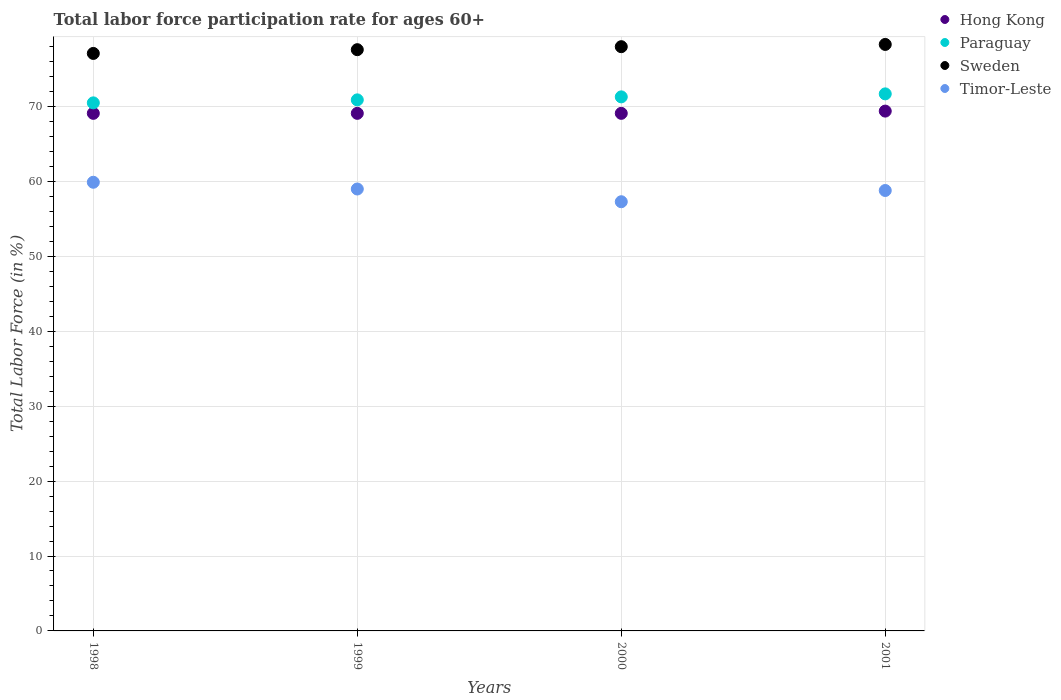Is the number of dotlines equal to the number of legend labels?
Provide a succinct answer. Yes. What is the labor force participation rate in Timor-Leste in 2001?
Your answer should be compact. 58.8. Across all years, what is the maximum labor force participation rate in Timor-Leste?
Provide a short and direct response. 59.9. Across all years, what is the minimum labor force participation rate in Timor-Leste?
Provide a succinct answer. 57.3. What is the total labor force participation rate in Paraguay in the graph?
Give a very brief answer. 284.4. What is the difference between the labor force participation rate in Paraguay in 1998 and that in 2001?
Make the answer very short. -1.2. What is the difference between the labor force participation rate in Timor-Leste in 1999 and the labor force participation rate in Paraguay in 2000?
Your answer should be compact. -12.3. What is the average labor force participation rate in Paraguay per year?
Your answer should be very brief. 71.1. In how many years, is the labor force participation rate in Timor-Leste greater than 28 %?
Keep it short and to the point. 4. What is the ratio of the labor force participation rate in Sweden in 1998 to that in 1999?
Offer a very short reply. 0.99. What is the difference between the highest and the second highest labor force participation rate in Sweden?
Offer a very short reply. 0.3. What is the difference between the highest and the lowest labor force participation rate in Hong Kong?
Keep it short and to the point. 0.3. In how many years, is the labor force participation rate in Hong Kong greater than the average labor force participation rate in Hong Kong taken over all years?
Your response must be concise. 1. Is it the case that in every year, the sum of the labor force participation rate in Sweden and labor force participation rate in Paraguay  is greater than the sum of labor force participation rate in Hong Kong and labor force participation rate in Timor-Leste?
Offer a very short reply. Yes. Is the labor force participation rate in Paraguay strictly less than the labor force participation rate in Sweden over the years?
Offer a very short reply. Yes. How many years are there in the graph?
Provide a short and direct response. 4. Where does the legend appear in the graph?
Offer a very short reply. Top right. What is the title of the graph?
Ensure brevity in your answer.  Total labor force participation rate for ages 60+. What is the Total Labor Force (in %) of Hong Kong in 1998?
Ensure brevity in your answer.  69.1. What is the Total Labor Force (in %) of Paraguay in 1998?
Offer a very short reply. 70.5. What is the Total Labor Force (in %) in Sweden in 1998?
Keep it short and to the point. 77.1. What is the Total Labor Force (in %) in Timor-Leste in 1998?
Your response must be concise. 59.9. What is the Total Labor Force (in %) in Hong Kong in 1999?
Make the answer very short. 69.1. What is the Total Labor Force (in %) in Paraguay in 1999?
Make the answer very short. 70.9. What is the Total Labor Force (in %) of Sweden in 1999?
Your response must be concise. 77.6. What is the Total Labor Force (in %) of Timor-Leste in 1999?
Your response must be concise. 59. What is the Total Labor Force (in %) in Hong Kong in 2000?
Your response must be concise. 69.1. What is the Total Labor Force (in %) of Paraguay in 2000?
Offer a very short reply. 71.3. What is the Total Labor Force (in %) in Timor-Leste in 2000?
Your response must be concise. 57.3. What is the Total Labor Force (in %) in Hong Kong in 2001?
Make the answer very short. 69.4. What is the Total Labor Force (in %) of Paraguay in 2001?
Offer a very short reply. 71.7. What is the Total Labor Force (in %) of Sweden in 2001?
Your response must be concise. 78.3. What is the Total Labor Force (in %) of Timor-Leste in 2001?
Ensure brevity in your answer.  58.8. Across all years, what is the maximum Total Labor Force (in %) in Hong Kong?
Offer a terse response. 69.4. Across all years, what is the maximum Total Labor Force (in %) of Paraguay?
Keep it short and to the point. 71.7. Across all years, what is the maximum Total Labor Force (in %) in Sweden?
Provide a succinct answer. 78.3. Across all years, what is the maximum Total Labor Force (in %) in Timor-Leste?
Keep it short and to the point. 59.9. Across all years, what is the minimum Total Labor Force (in %) in Hong Kong?
Your answer should be compact. 69.1. Across all years, what is the minimum Total Labor Force (in %) of Paraguay?
Ensure brevity in your answer.  70.5. Across all years, what is the minimum Total Labor Force (in %) in Sweden?
Ensure brevity in your answer.  77.1. Across all years, what is the minimum Total Labor Force (in %) of Timor-Leste?
Provide a short and direct response. 57.3. What is the total Total Labor Force (in %) in Hong Kong in the graph?
Your answer should be very brief. 276.7. What is the total Total Labor Force (in %) of Paraguay in the graph?
Your answer should be very brief. 284.4. What is the total Total Labor Force (in %) of Sweden in the graph?
Your answer should be very brief. 311. What is the total Total Labor Force (in %) in Timor-Leste in the graph?
Offer a very short reply. 235. What is the difference between the Total Labor Force (in %) in Hong Kong in 1998 and that in 1999?
Give a very brief answer. 0. What is the difference between the Total Labor Force (in %) of Paraguay in 1998 and that in 1999?
Your answer should be very brief. -0.4. What is the difference between the Total Labor Force (in %) of Sweden in 1998 and that in 1999?
Offer a very short reply. -0.5. What is the difference between the Total Labor Force (in %) in Timor-Leste in 1998 and that in 1999?
Your answer should be very brief. 0.9. What is the difference between the Total Labor Force (in %) in Paraguay in 1998 and that in 2000?
Ensure brevity in your answer.  -0.8. What is the difference between the Total Labor Force (in %) in Timor-Leste in 1998 and that in 2000?
Provide a short and direct response. 2.6. What is the difference between the Total Labor Force (in %) in Paraguay in 1998 and that in 2001?
Offer a very short reply. -1.2. What is the difference between the Total Labor Force (in %) of Sweden in 1998 and that in 2001?
Offer a terse response. -1.2. What is the difference between the Total Labor Force (in %) in Timor-Leste in 1998 and that in 2001?
Keep it short and to the point. 1.1. What is the difference between the Total Labor Force (in %) of Hong Kong in 1999 and that in 2000?
Offer a very short reply. 0. What is the difference between the Total Labor Force (in %) of Paraguay in 1999 and that in 2000?
Your answer should be very brief. -0.4. What is the difference between the Total Labor Force (in %) of Sweden in 1999 and that in 2001?
Your answer should be very brief. -0.7. What is the difference between the Total Labor Force (in %) of Timor-Leste in 1999 and that in 2001?
Ensure brevity in your answer.  0.2. What is the difference between the Total Labor Force (in %) in Sweden in 2000 and that in 2001?
Keep it short and to the point. -0.3. What is the difference between the Total Labor Force (in %) of Hong Kong in 1998 and the Total Labor Force (in %) of Sweden in 1999?
Offer a very short reply. -8.5. What is the difference between the Total Labor Force (in %) in Sweden in 1998 and the Total Labor Force (in %) in Timor-Leste in 1999?
Provide a short and direct response. 18.1. What is the difference between the Total Labor Force (in %) of Hong Kong in 1998 and the Total Labor Force (in %) of Sweden in 2000?
Give a very brief answer. -8.9. What is the difference between the Total Labor Force (in %) in Hong Kong in 1998 and the Total Labor Force (in %) in Timor-Leste in 2000?
Keep it short and to the point. 11.8. What is the difference between the Total Labor Force (in %) of Paraguay in 1998 and the Total Labor Force (in %) of Sweden in 2000?
Ensure brevity in your answer.  -7.5. What is the difference between the Total Labor Force (in %) of Sweden in 1998 and the Total Labor Force (in %) of Timor-Leste in 2000?
Give a very brief answer. 19.8. What is the difference between the Total Labor Force (in %) of Hong Kong in 1998 and the Total Labor Force (in %) of Sweden in 2001?
Keep it short and to the point. -9.2. What is the difference between the Total Labor Force (in %) of Hong Kong in 1998 and the Total Labor Force (in %) of Timor-Leste in 2001?
Your response must be concise. 10.3. What is the difference between the Total Labor Force (in %) of Paraguay in 1998 and the Total Labor Force (in %) of Sweden in 2001?
Provide a succinct answer. -7.8. What is the difference between the Total Labor Force (in %) in Sweden in 1998 and the Total Labor Force (in %) in Timor-Leste in 2001?
Offer a terse response. 18.3. What is the difference between the Total Labor Force (in %) in Hong Kong in 1999 and the Total Labor Force (in %) in Paraguay in 2000?
Provide a succinct answer. -2.2. What is the difference between the Total Labor Force (in %) of Hong Kong in 1999 and the Total Labor Force (in %) of Timor-Leste in 2000?
Your answer should be very brief. 11.8. What is the difference between the Total Labor Force (in %) of Paraguay in 1999 and the Total Labor Force (in %) of Sweden in 2000?
Your answer should be very brief. -7.1. What is the difference between the Total Labor Force (in %) in Sweden in 1999 and the Total Labor Force (in %) in Timor-Leste in 2000?
Provide a short and direct response. 20.3. What is the difference between the Total Labor Force (in %) in Hong Kong in 1999 and the Total Labor Force (in %) in Timor-Leste in 2001?
Provide a short and direct response. 10.3. What is the difference between the Total Labor Force (in %) of Paraguay in 1999 and the Total Labor Force (in %) of Timor-Leste in 2001?
Make the answer very short. 12.1. What is the difference between the Total Labor Force (in %) in Hong Kong in 2000 and the Total Labor Force (in %) in Paraguay in 2001?
Offer a terse response. -2.6. What is the difference between the Total Labor Force (in %) of Hong Kong in 2000 and the Total Labor Force (in %) of Timor-Leste in 2001?
Offer a terse response. 10.3. What is the difference between the Total Labor Force (in %) in Sweden in 2000 and the Total Labor Force (in %) in Timor-Leste in 2001?
Your answer should be compact. 19.2. What is the average Total Labor Force (in %) of Hong Kong per year?
Offer a terse response. 69.17. What is the average Total Labor Force (in %) in Paraguay per year?
Ensure brevity in your answer.  71.1. What is the average Total Labor Force (in %) in Sweden per year?
Ensure brevity in your answer.  77.75. What is the average Total Labor Force (in %) of Timor-Leste per year?
Offer a terse response. 58.75. In the year 1998, what is the difference between the Total Labor Force (in %) in Hong Kong and Total Labor Force (in %) in Paraguay?
Ensure brevity in your answer.  -1.4. In the year 1998, what is the difference between the Total Labor Force (in %) in Hong Kong and Total Labor Force (in %) in Sweden?
Your answer should be compact. -8. In the year 1998, what is the difference between the Total Labor Force (in %) in Hong Kong and Total Labor Force (in %) in Timor-Leste?
Provide a short and direct response. 9.2. In the year 1998, what is the difference between the Total Labor Force (in %) of Sweden and Total Labor Force (in %) of Timor-Leste?
Make the answer very short. 17.2. In the year 1999, what is the difference between the Total Labor Force (in %) of Hong Kong and Total Labor Force (in %) of Paraguay?
Give a very brief answer. -1.8. In the year 1999, what is the difference between the Total Labor Force (in %) in Paraguay and Total Labor Force (in %) in Timor-Leste?
Your answer should be very brief. 11.9. In the year 2000, what is the difference between the Total Labor Force (in %) in Hong Kong and Total Labor Force (in %) in Sweden?
Give a very brief answer. -8.9. In the year 2000, what is the difference between the Total Labor Force (in %) in Sweden and Total Labor Force (in %) in Timor-Leste?
Offer a very short reply. 20.7. In the year 2001, what is the difference between the Total Labor Force (in %) of Hong Kong and Total Labor Force (in %) of Paraguay?
Make the answer very short. -2.3. In the year 2001, what is the difference between the Total Labor Force (in %) of Hong Kong and Total Labor Force (in %) of Sweden?
Keep it short and to the point. -8.9. In the year 2001, what is the difference between the Total Labor Force (in %) of Paraguay and Total Labor Force (in %) of Timor-Leste?
Keep it short and to the point. 12.9. In the year 2001, what is the difference between the Total Labor Force (in %) in Sweden and Total Labor Force (in %) in Timor-Leste?
Make the answer very short. 19.5. What is the ratio of the Total Labor Force (in %) in Paraguay in 1998 to that in 1999?
Keep it short and to the point. 0.99. What is the ratio of the Total Labor Force (in %) of Sweden in 1998 to that in 1999?
Your response must be concise. 0.99. What is the ratio of the Total Labor Force (in %) of Timor-Leste in 1998 to that in 1999?
Provide a succinct answer. 1.02. What is the ratio of the Total Labor Force (in %) of Hong Kong in 1998 to that in 2000?
Your answer should be compact. 1. What is the ratio of the Total Labor Force (in %) in Timor-Leste in 1998 to that in 2000?
Give a very brief answer. 1.05. What is the ratio of the Total Labor Force (in %) in Paraguay in 1998 to that in 2001?
Provide a short and direct response. 0.98. What is the ratio of the Total Labor Force (in %) of Sweden in 1998 to that in 2001?
Provide a short and direct response. 0.98. What is the ratio of the Total Labor Force (in %) in Timor-Leste in 1998 to that in 2001?
Provide a succinct answer. 1.02. What is the ratio of the Total Labor Force (in %) in Paraguay in 1999 to that in 2000?
Offer a very short reply. 0.99. What is the ratio of the Total Labor Force (in %) in Sweden in 1999 to that in 2000?
Make the answer very short. 0.99. What is the ratio of the Total Labor Force (in %) in Timor-Leste in 1999 to that in 2000?
Make the answer very short. 1.03. What is the ratio of the Total Labor Force (in %) of Sweden in 1999 to that in 2001?
Your response must be concise. 0.99. What is the ratio of the Total Labor Force (in %) in Paraguay in 2000 to that in 2001?
Keep it short and to the point. 0.99. What is the ratio of the Total Labor Force (in %) in Sweden in 2000 to that in 2001?
Provide a short and direct response. 1. What is the ratio of the Total Labor Force (in %) of Timor-Leste in 2000 to that in 2001?
Your response must be concise. 0.97. What is the difference between the highest and the second highest Total Labor Force (in %) of Hong Kong?
Your answer should be compact. 0.3. What is the difference between the highest and the lowest Total Labor Force (in %) in Sweden?
Ensure brevity in your answer.  1.2. What is the difference between the highest and the lowest Total Labor Force (in %) of Timor-Leste?
Your answer should be compact. 2.6. 